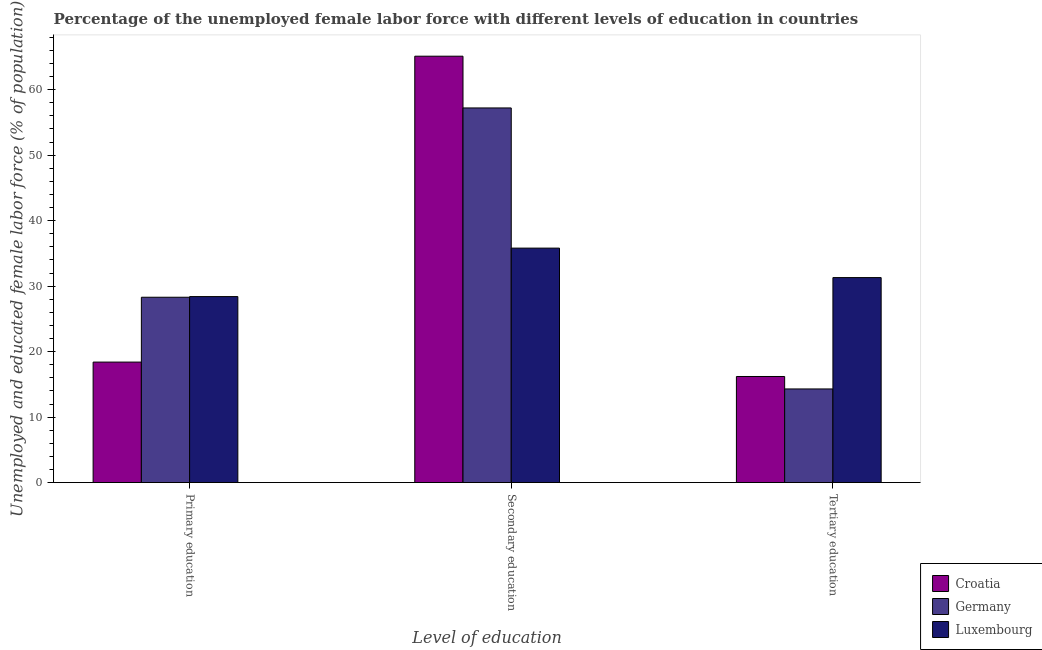How many different coloured bars are there?
Your response must be concise. 3. How many groups of bars are there?
Make the answer very short. 3. How many bars are there on the 2nd tick from the left?
Your answer should be compact. 3. What is the label of the 2nd group of bars from the left?
Provide a succinct answer. Secondary education. What is the percentage of female labor force who received tertiary education in Germany?
Make the answer very short. 14.3. Across all countries, what is the maximum percentage of female labor force who received secondary education?
Keep it short and to the point. 65.1. Across all countries, what is the minimum percentage of female labor force who received primary education?
Keep it short and to the point. 18.4. In which country was the percentage of female labor force who received tertiary education maximum?
Your answer should be very brief. Luxembourg. In which country was the percentage of female labor force who received secondary education minimum?
Give a very brief answer. Luxembourg. What is the total percentage of female labor force who received primary education in the graph?
Your answer should be very brief. 75.1. What is the difference between the percentage of female labor force who received tertiary education in Croatia and that in Luxembourg?
Ensure brevity in your answer.  -15.1. What is the difference between the percentage of female labor force who received tertiary education in Croatia and the percentage of female labor force who received primary education in Germany?
Offer a very short reply. -12.1. What is the average percentage of female labor force who received primary education per country?
Offer a terse response. 25.03. What is the difference between the percentage of female labor force who received primary education and percentage of female labor force who received secondary education in Croatia?
Offer a very short reply. -46.7. In how many countries, is the percentage of female labor force who received tertiary education greater than 30 %?
Your answer should be compact. 1. What is the ratio of the percentage of female labor force who received primary education in Croatia to that in Luxembourg?
Make the answer very short. 0.65. Is the percentage of female labor force who received secondary education in Germany less than that in Luxembourg?
Ensure brevity in your answer.  No. What is the difference between the highest and the second highest percentage of female labor force who received tertiary education?
Offer a very short reply. 15.1. What is the difference between the highest and the lowest percentage of female labor force who received tertiary education?
Give a very brief answer. 17. Is the sum of the percentage of female labor force who received secondary education in Croatia and Luxembourg greater than the maximum percentage of female labor force who received tertiary education across all countries?
Make the answer very short. Yes. What does the 2nd bar from the left in Tertiary education represents?
Your answer should be compact. Germany. What does the 3rd bar from the right in Primary education represents?
Offer a terse response. Croatia. How many bars are there?
Your answer should be compact. 9. How many countries are there in the graph?
Offer a terse response. 3. What is the difference between two consecutive major ticks on the Y-axis?
Give a very brief answer. 10. Are the values on the major ticks of Y-axis written in scientific E-notation?
Provide a short and direct response. No. Does the graph contain any zero values?
Make the answer very short. No. Does the graph contain grids?
Provide a succinct answer. No. Where does the legend appear in the graph?
Provide a succinct answer. Bottom right. How many legend labels are there?
Keep it short and to the point. 3. How are the legend labels stacked?
Provide a succinct answer. Vertical. What is the title of the graph?
Keep it short and to the point. Percentage of the unemployed female labor force with different levels of education in countries. What is the label or title of the X-axis?
Ensure brevity in your answer.  Level of education. What is the label or title of the Y-axis?
Your response must be concise. Unemployed and educated female labor force (% of population). What is the Unemployed and educated female labor force (% of population) in Croatia in Primary education?
Your response must be concise. 18.4. What is the Unemployed and educated female labor force (% of population) in Germany in Primary education?
Your answer should be very brief. 28.3. What is the Unemployed and educated female labor force (% of population) of Luxembourg in Primary education?
Make the answer very short. 28.4. What is the Unemployed and educated female labor force (% of population) of Croatia in Secondary education?
Offer a terse response. 65.1. What is the Unemployed and educated female labor force (% of population) in Germany in Secondary education?
Make the answer very short. 57.2. What is the Unemployed and educated female labor force (% of population) of Luxembourg in Secondary education?
Provide a short and direct response. 35.8. What is the Unemployed and educated female labor force (% of population) of Croatia in Tertiary education?
Your answer should be very brief. 16.2. What is the Unemployed and educated female labor force (% of population) of Germany in Tertiary education?
Provide a succinct answer. 14.3. What is the Unemployed and educated female labor force (% of population) in Luxembourg in Tertiary education?
Your answer should be compact. 31.3. Across all Level of education, what is the maximum Unemployed and educated female labor force (% of population) of Croatia?
Your response must be concise. 65.1. Across all Level of education, what is the maximum Unemployed and educated female labor force (% of population) in Germany?
Keep it short and to the point. 57.2. Across all Level of education, what is the maximum Unemployed and educated female labor force (% of population) of Luxembourg?
Make the answer very short. 35.8. Across all Level of education, what is the minimum Unemployed and educated female labor force (% of population) in Croatia?
Provide a succinct answer. 16.2. Across all Level of education, what is the minimum Unemployed and educated female labor force (% of population) of Germany?
Your response must be concise. 14.3. Across all Level of education, what is the minimum Unemployed and educated female labor force (% of population) in Luxembourg?
Offer a terse response. 28.4. What is the total Unemployed and educated female labor force (% of population) in Croatia in the graph?
Provide a succinct answer. 99.7. What is the total Unemployed and educated female labor force (% of population) in Germany in the graph?
Offer a terse response. 99.8. What is the total Unemployed and educated female labor force (% of population) of Luxembourg in the graph?
Provide a short and direct response. 95.5. What is the difference between the Unemployed and educated female labor force (% of population) in Croatia in Primary education and that in Secondary education?
Offer a terse response. -46.7. What is the difference between the Unemployed and educated female labor force (% of population) of Germany in Primary education and that in Secondary education?
Ensure brevity in your answer.  -28.9. What is the difference between the Unemployed and educated female labor force (% of population) in Luxembourg in Primary education and that in Secondary education?
Offer a very short reply. -7.4. What is the difference between the Unemployed and educated female labor force (% of population) in Germany in Primary education and that in Tertiary education?
Your response must be concise. 14. What is the difference between the Unemployed and educated female labor force (% of population) of Luxembourg in Primary education and that in Tertiary education?
Provide a succinct answer. -2.9. What is the difference between the Unemployed and educated female labor force (% of population) in Croatia in Secondary education and that in Tertiary education?
Ensure brevity in your answer.  48.9. What is the difference between the Unemployed and educated female labor force (% of population) of Germany in Secondary education and that in Tertiary education?
Make the answer very short. 42.9. What is the difference between the Unemployed and educated female labor force (% of population) of Croatia in Primary education and the Unemployed and educated female labor force (% of population) of Germany in Secondary education?
Ensure brevity in your answer.  -38.8. What is the difference between the Unemployed and educated female labor force (% of population) in Croatia in Primary education and the Unemployed and educated female labor force (% of population) in Luxembourg in Secondary education?
Ensure brevity in your answer.  -17.4. What is the difference between the Unemployed and educated female labor force (% of population) in Germany in Primary education and the Unemployed and educated female labor force (% of population) in Luxembourg in Secondary education?
Provide a short and direct response. -7.5. What is the difference between the Unemployed and educated female labor force (% of population) in Croatia in Secondary education and the Unemployed and educated female labor force (% of population) in Germany in Tertiary education?
Provide a short and direct response. 50.8. What is the difference between the Unemployed and educated female labor force (% of population) in Croatia in Secondary education and the Unemployed and educated female labor force (% of population) in Luxembourg in Tertiary education?
Offer a very short reply. 33.8. What is the difference between the Unemployed and educated female labor force (% of population) in Germany in Secondary education and the Unemployed and educated female labor force (% of population) in Luxembourg in Tertiary education?
Offer a very short reply. 25.9. What is the average Unemployed and educated female labor force (% of population) of Croatia per Level of education?
Make the answer very short. 33.23. What is the average Unemployed and educated female labor force (% of population) of Germany per Level of education?
Offer a terse response. 33.27. What is the average Unemployed and educated female labor force (% of population) in Luxembourg per Level of education?
Keep it short and to the point. 31.83. What is the difference between the Unemployed and educated female labor force (% of population) of Croatia and Unemployed and educated female labor force (% of population) of Germany in Primary education?
Your answer should be compact. -9.9. What is the difference between the Unemployed and educated female labor force (% of population) of Croatia and Unemployed and educated female labor force (% of population) of Luxembourg in Secondary education?
Provide a succinct answer. 29.3. What is the difference between the Unemployed and educated female labor force (% of population) of Germany and Unemployed and educated female labor force (% of population) of Luxembourg in Secondary education?
Give a very brief answer. 21.4. What is the difference between the Unemployed and educated female labor force (% of population) in Croatia and Unemployed and educated female labor force (% of population) in Luxembourg in Tertiary education?
Your answer should be compact. -15.1. What is the ratio of the Unemployed and educated female labor force (% of population) of Croatia in Primary education to that in Secondary education?
Provide a succinct answer. 0.28. What is the ratio of the Unemployed and educated female labor force (% of population) of Germany in Primary education to that in Secondary education?
Your answer should be compact. 0.49. What is the ratio of the Unemployed and educated female labor force (% of population) of Luxembourg in Primary education to that in Secondary education?
Ensure brevity in your answer.  0.79. What is the ratio of the Unemployed and educated female labor force (% of population) of Croatia in Primary education to that in Tertiary education?
Offer a very short reply. 1.14. What is the ratio of the Unemployed and educated female labor force (% of population) of Germany in Primary education to that in Tertiary education?
Your response must be concise. 1.98. What is the ratio of the Unemployed and educated female labor force (% of population) of Luxembourg in Primary education to that in Tertiary education?
Provide a succinct answer. 0.91. What is the ratio of the Unemployed and educated female labor force (% of population) in Croatia in Secondary education to that in Tertiary education?
Provide a succinct answer. 4.02. What is the ratio of the Unemployed and educated female labor force (% of population) of Luxembourg in Secondary education to that in Tertiary education?
Your answer should be compact. 1.14. What is the difference between the highest and the second highest Unemployed and educated female labor force (% of population) of Croatia?
Your response must be concise. 46.7. What is the difference between the highest and the second highest Unemployed and educated female labor force (% of population) of Germany?
Your response must be concise. 28.9. What is the difference between the highest and the lowest Unemployed and educated female labor force (% of population) of Croatia?
Your answer should be very brief. 48.9. What is the difference between the highest and the lowest Unemployed and educated female labor force (% of population) in Germany?
Give a very brief answer. 42.9. 